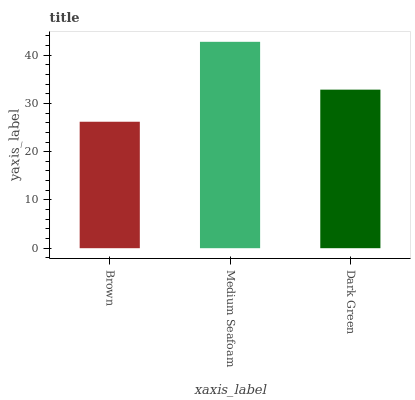Is Brown the minimum?
Answer yes or no. Yes. Is Medium Seafoam the maximum?
Answer yes or no. Yes. Is Dark Green the minimum?
Answer yes or no. No. Is Dark Green the maximum?
Answer yes or no. No. Is Medium Seafoam greater than Dark Green?
Answer yes or no. Yes. Is Dark Green less than Medium Seafoam?
Answer yes or no. Yes. Is Dark Green greater than Medium Seafoam?
Answer yes or no. No. Is Medium Seafoam less than Dark Green?
Answer yes or no. No. Is Dark Green the high median?
Answer yes or no. Yes. Is Dark Green the low median?
Answer yes or no. Yes. Is Brown the high median?
Answer yes or no. No. Is Brown the low median?
Answer yes or no. No. 